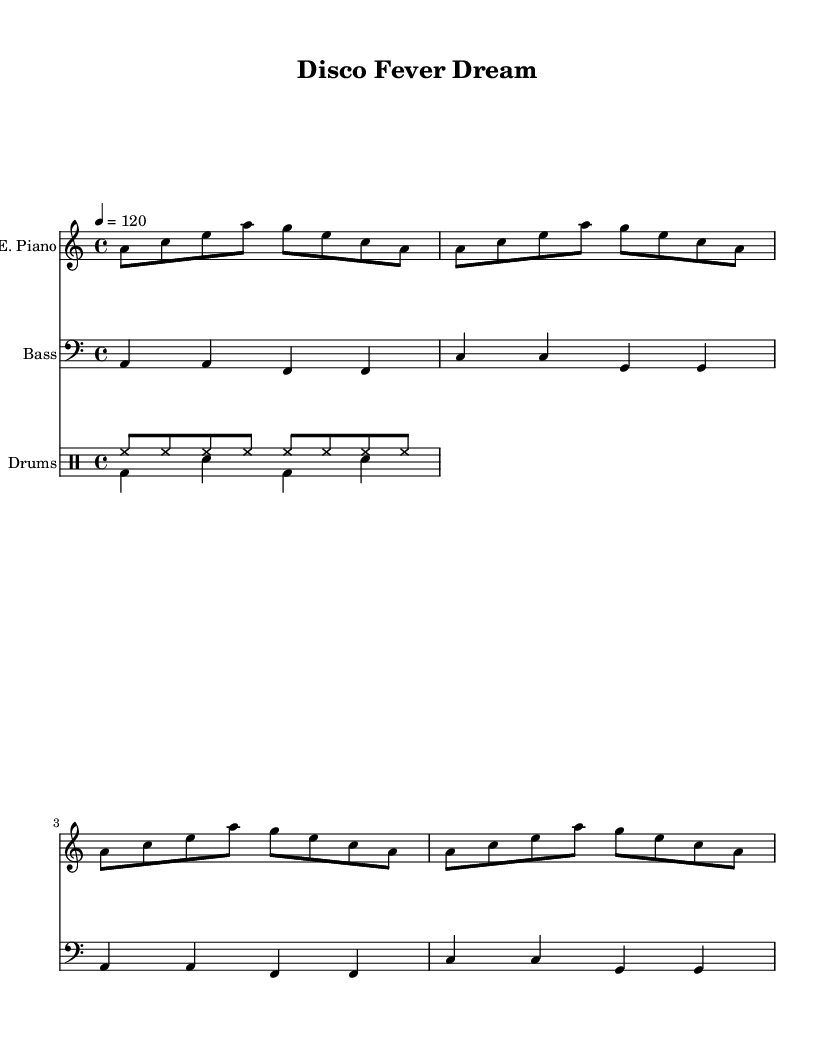What is the key signature of this music? The key signature is A minor, which has no sharps or flats.
Answer: A minor What is the time signature of the piece? The time signature is 4/4, indicating four beats per measure.
Answer: 4/4 What is the tempo marking given in the score? The tempo marking is quarter note equals 120 beats per minute.
Answer: 120 How many measures are there in the electric piano part? There are four measures in the electric piano part, each showcasing a repetitive pattern.
Answer: 4 What is the primary instrument listed in the drum staff? The primary instrument in the drum staff is drums, which includes both hi-hat and bass drum patterns.
Answer: Drums What is the rhythmic pattern used in the bass guitar section? The bass guitar uses a repeating pattern over two measures, alternating notes in a rhythmic structure.
Answer: Repeating pattern Explain the role of the hi-hat in the drum part. The hi-hat plays consistently throughout the measures, maintaining a steady eighth note rhythm that enhances the dance feel of the disco style.
Answer: Steady eighth notes 